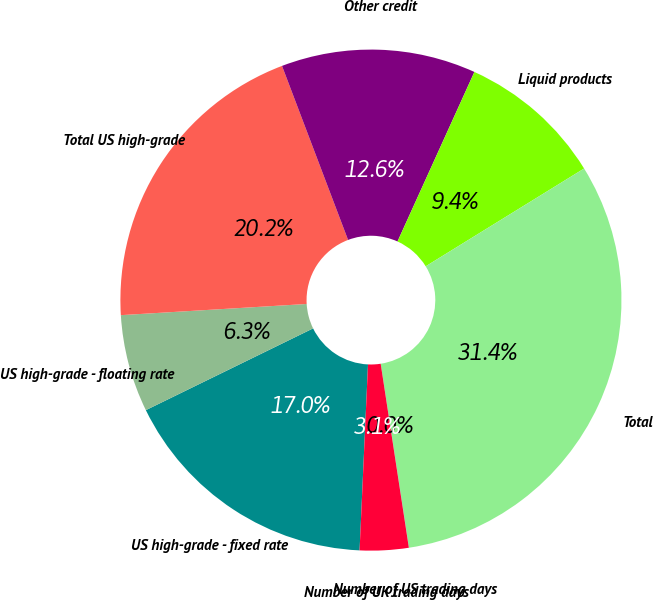<chart> <loc_0><loc_0><loc_500><loc_500><pie_chart><fcel>US high-grade - fixed rate<fcel>US high-grade - floating rate<fcel>Total US high-grade<fcel>Other credit<fcel>Liquid products<fcel>Total<fcel>Number of US trading days<fcel>Number of UK trading days<nl><fcel>17.04%<fcel>6.28%<fcel>20.18%<fcel>12.55%<fcel>9.42%<fcel>31.37%<fcel>0.01%<fcel>3.14%<nl></chart> 